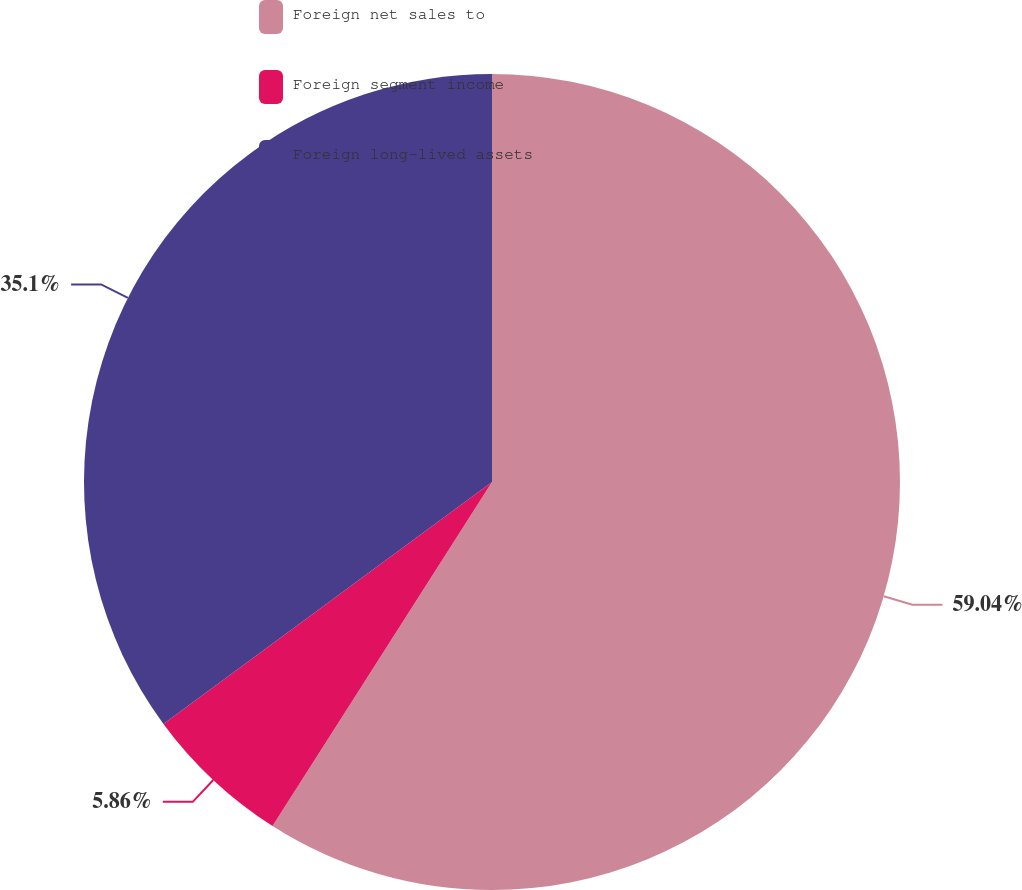<chart> <loc_0><loc_0><loc_500><loc_500><pie_chart><fcel>Foreign net sales to<fcel>Foreign segment income<fcel>Foreign long-lived assets<nl><fcel>59.04%<fcel>5.86%<fcel>35.1%<nl></chart> 